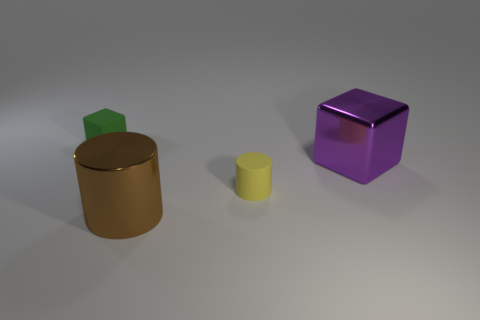Subtract all cyan cylinders. Subtract all red spheres. How many cylinders are left? 2 Add 4 gray metal blocks. How many objects exist? 8 Add 4 brown things. How many brown things exist? 5 Subtract 0 red blocks. How many objects are left? 4 Subtract all spheres. Subtract all large brown metallic cylinders. How many objects are left? 3 Add 4 yellow rubber cylinders. How many yellow rubber cylinders are left? 5 